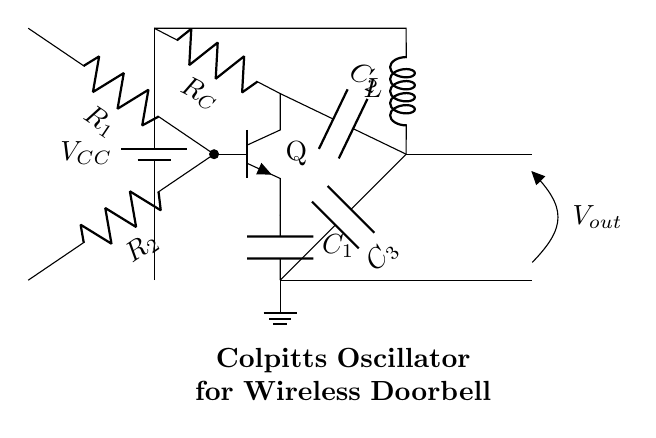What is the power supply voltage in this circuit? The power supply voltage is denoted by V CC at the top of the circuit. It is typically a constant value, which is often in the range of 5 to 15 volts for electronic circuits.
Answer: V CC What type of transistor is used in this oscillator? The circuit diagram shows a transistor labeled Q, which is an npn type. This can be identified by the labeling and general symbol used in circuit diagrams for this type of transistor.
Answer: npn How many capacitors are present in the circuit? The diagram shows three distinct capacitors labeled C1, C2, and C3. Each component is denoted with a "C" followed by a number, indicating their quantity in the circuit.
Answer: 3 What is the function of the inductor in this oscillator? The inductor, labeled L, plays a crucial role in determining the oscillation frequency of the circuit in conjunction with the capacitors. Inductors in oscillator circuits help create a resonant LC circuit for oscillation.
Answer: Frequency determination What is the role of resistors R1 and R2? Resistors R1 and R2 are part of the voltage divider network that sets the biasing for the transistor’s base. Proper biasing is required for the transistor to operate in the correct region, enabling oscillation.
Answer: Transistor biasing What is indicated by the output voltage labeled as Vout? Vout is the voltage that represents the output of the oscillator circuit. It is taken from a point after the oscillator’s active components and indicates the generated radio frequency output for the wireless doorbell function.
Answer: Oscillator output 